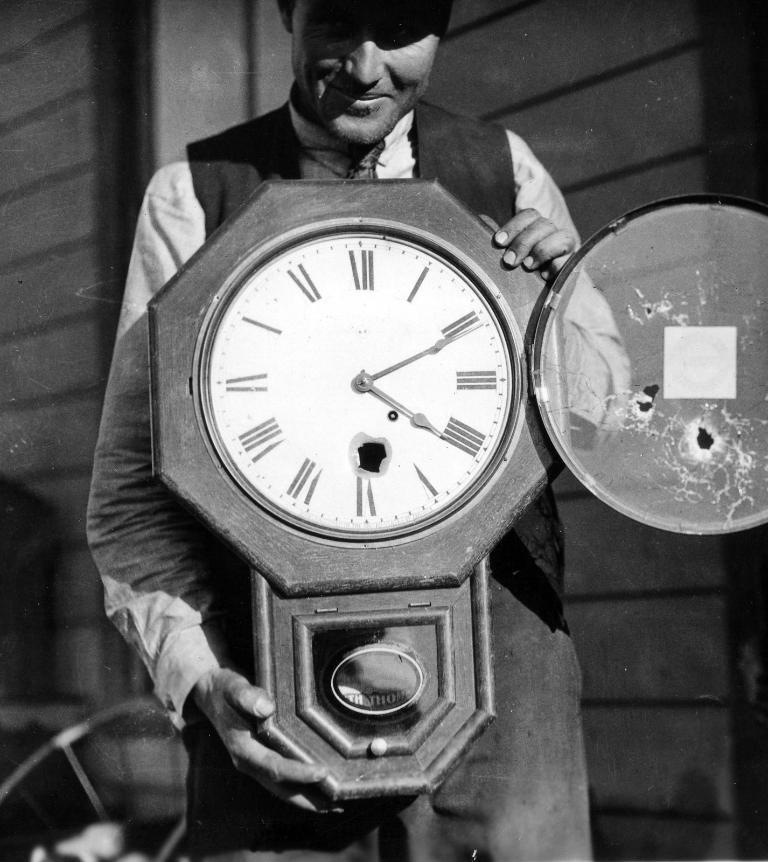What time is it?
Your answer should be very brief. 4:11. 